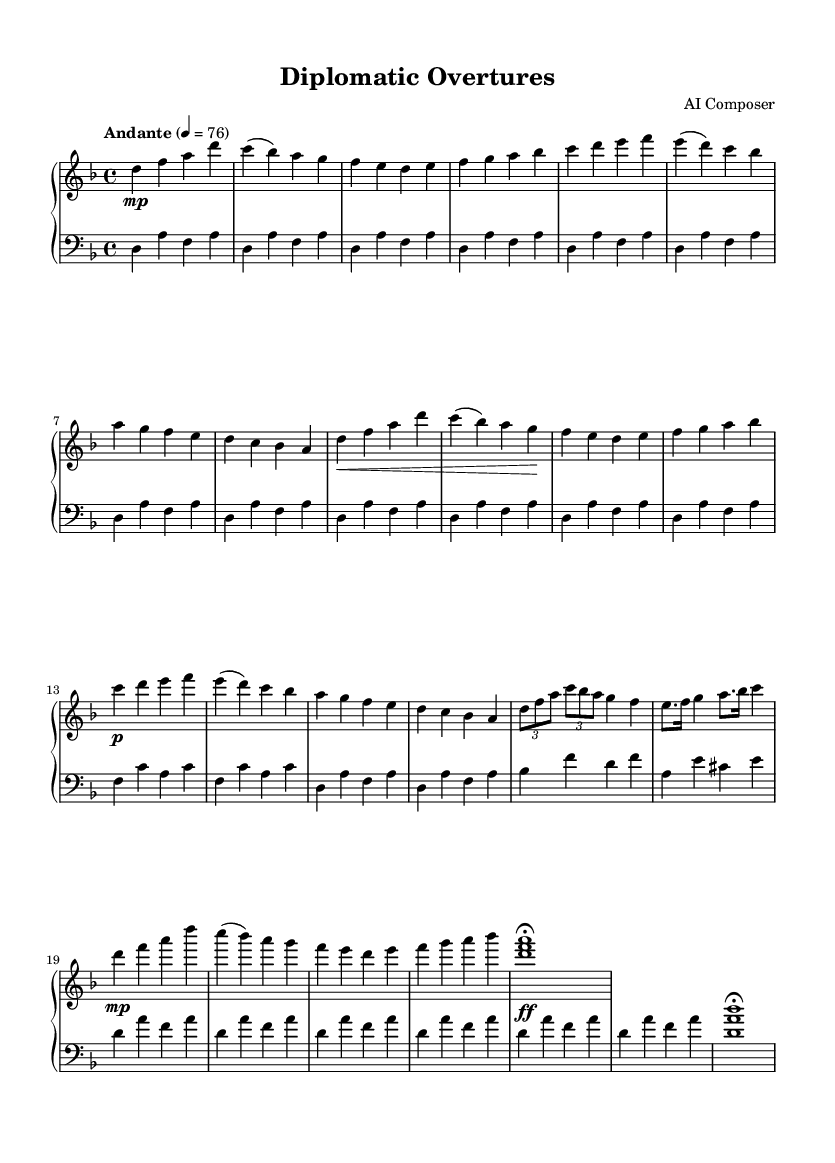what is the key signature of this music? The key signature is indicated at the beginning of the staff and shows two flats, which designates it as D minor.
Answer: D minor what is the time signature of this music? The time signature is found at the beginning and is written as a fraction with the upper number showing 4 and the lower number showing 4, indicating that there are four beats per measure and a quarter note receives one beat.
Answer: 4/4 what is the tempo marking of the piece? The tempo marking is found near the beginning of the score and indicates "Andante," which describes a moderately slow pace.
Answer: Andante how many distinct themes are present in this piece? By analyzing the structure of the score, it is evident that there are two distinct themes, labeled as Theme A and Theme B, which are repeated throughout the piece.
Answer: 2 what is the dynamic marking at the beginning of the right hand's introduction? In the score, the right hand's introduction begins with a dynamic marking of "mp," which stands for mezzopiano, indicating a moderately soft sound.
Answer: mp what section follows the development in this piece? By reviewing the structure provided in the score, after the development section, the next part is the recapitulation, which repeats the main themes.
Answer: Recapitulation how is the coda marked in the music? The coda section is marked with a specific notation and notated as "<d, f a>1" followed by a "fermata," indicating to hold the chord longer, serving as the closure of the piece.
Answer: <d, f a>1\fermata 